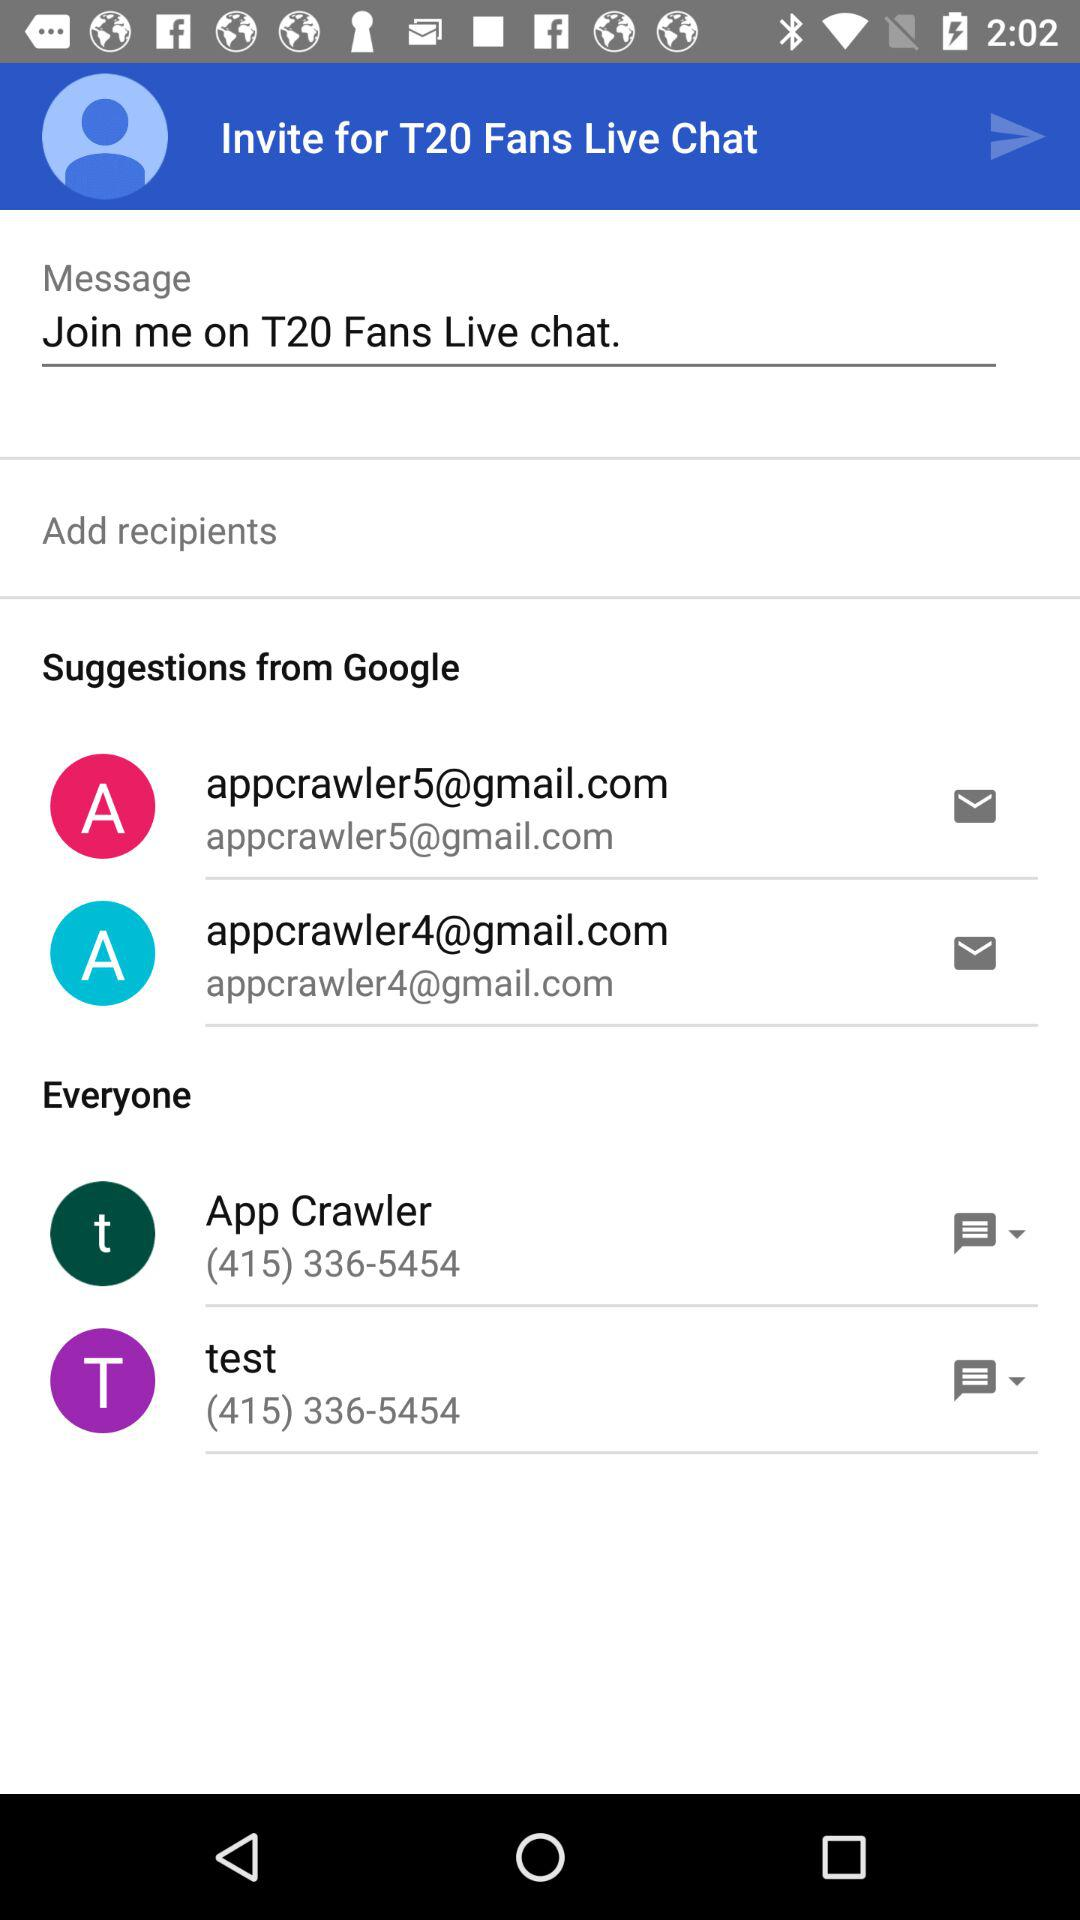What email addresses are there? The email addresses are appcrawler5@gmail.com and appcrawler5@gmail.com. 